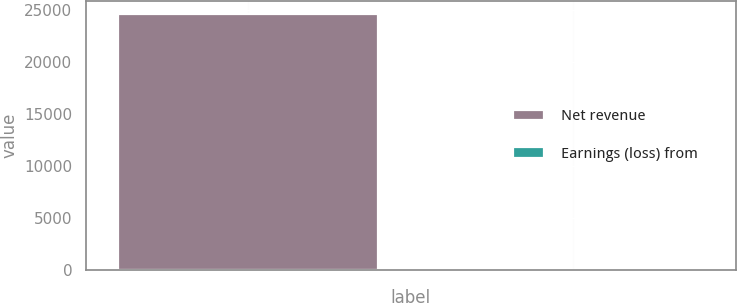Convert chart. <chart><loc_0><loc_0><loc_500><loc_500><bar_chart><fcel>Net revenue<fcel>Earnings (loss) from<nl><fcel>24622<fcel>0.9<nl></chart> 